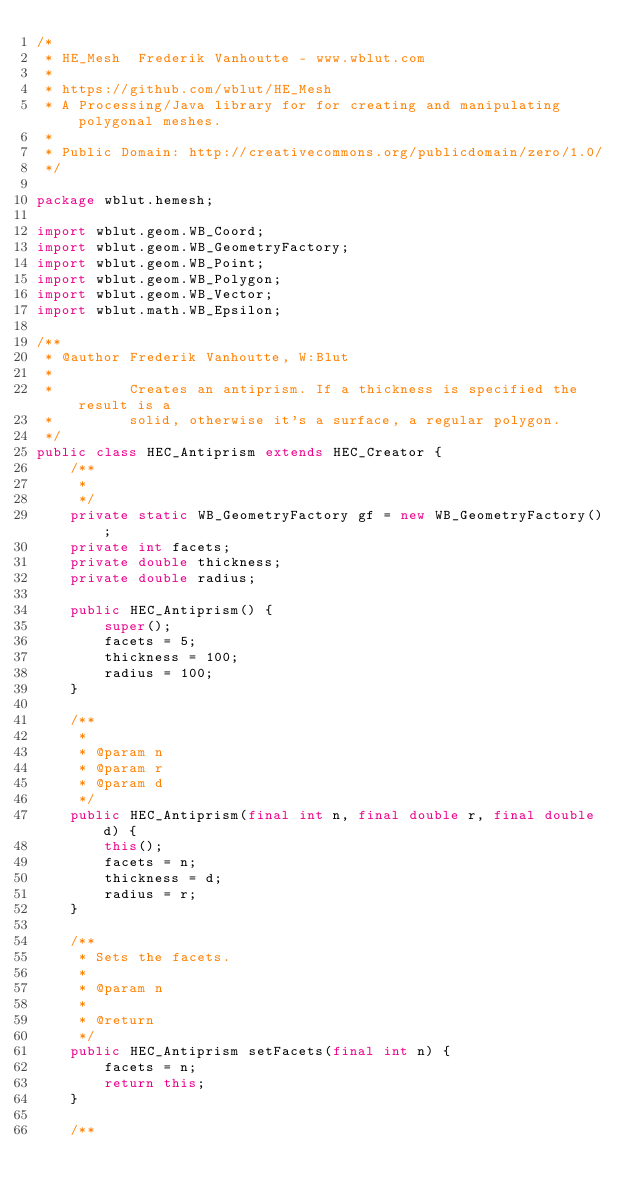<code> <loc_0><loc_0><loc_500><loc_500><_Java_>/*
 * HE_Mesh  Frederik Vanhoutte - www.wblut.com
 * 
 * https://github.com/wblut/HE_Mesh
 * A Processing/Java library for for creating and manipulating polygonal meshes.
 * 
 * Public Domain: http://creativecommons.org/publicdomain/zero/1.0/
 */

package wblut.hemesh;

import wblut.geom.WB_Coord;
import wblut.geom.WB_GeometryFactory;
import wblut.geom.WB_Point;
import wblut.geom.WB_Polygon;
import wblut.geom.WB_Vector;
import wblut.math.WB_Epsilon;

/**
 * @author Frederik Vanhoutte, W:Blut
 *
 *         Creates an antiprism. If a thickness is specified the result is a
 *         solid, otherwise it's a surface, a regular polygon.
 */
public class HEC_Antiprism extends HEC_Creator {
	/**
	 *
	 */
	private static WB_GeometryFactory gf = new WB_GeometryFactory();
	private int facets;
	private double thickness;
	private double radius;

	public HEC_Antiprism() {
		super();
		facets = 5;
		thickness = 100;
		radius = 100;
	}

	/**
	 *
	 * @param n
	 * @param r
	 * @param d
	 */
	public HEC_Antiprism(final int n, final double r, final double d) {
		this();
		facets = n;
		thickness = d;
		radius = r;
	}

	/**
	 * Sets the facets.
	 *
	 * @param n
	 *
	 * @return
	 */
	public HEC_Antiprism setFacets(final int n) {
		facets = n;
		return this;
	}

	/**</code> 